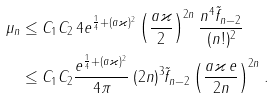Convert formula to latex. <formula><loc_0><loc_0><loc_500><loc_500>\mu _ { n } & \leq C _ { 1 } C _ { 2 } \, 4 e ^ { \frac { 1 } { 4 } + ( a \varkappa ) ^ { 2 } } \left ( \frac { a \varkappa } { 2 } \right ) ^ { 2 n } \frac { n ^ { 4 } \tilde { f } _ { n - 2 } } { ( n ! ) ^ { 2 } } \\ & \leq C _ { 1 } C _ { 2 } \frac { e ^ { \frac { 1 } { 4 } + ( a \varkappa ) ^ { 2 } } } { 4 \pi } \, ( 2 n ) ^ { 3 } \tilde { f } _ { n - 2 } \left ( \frac { a \varkappa \, e } { 2 n } \right ) ^ { 2 n } .</formula> 